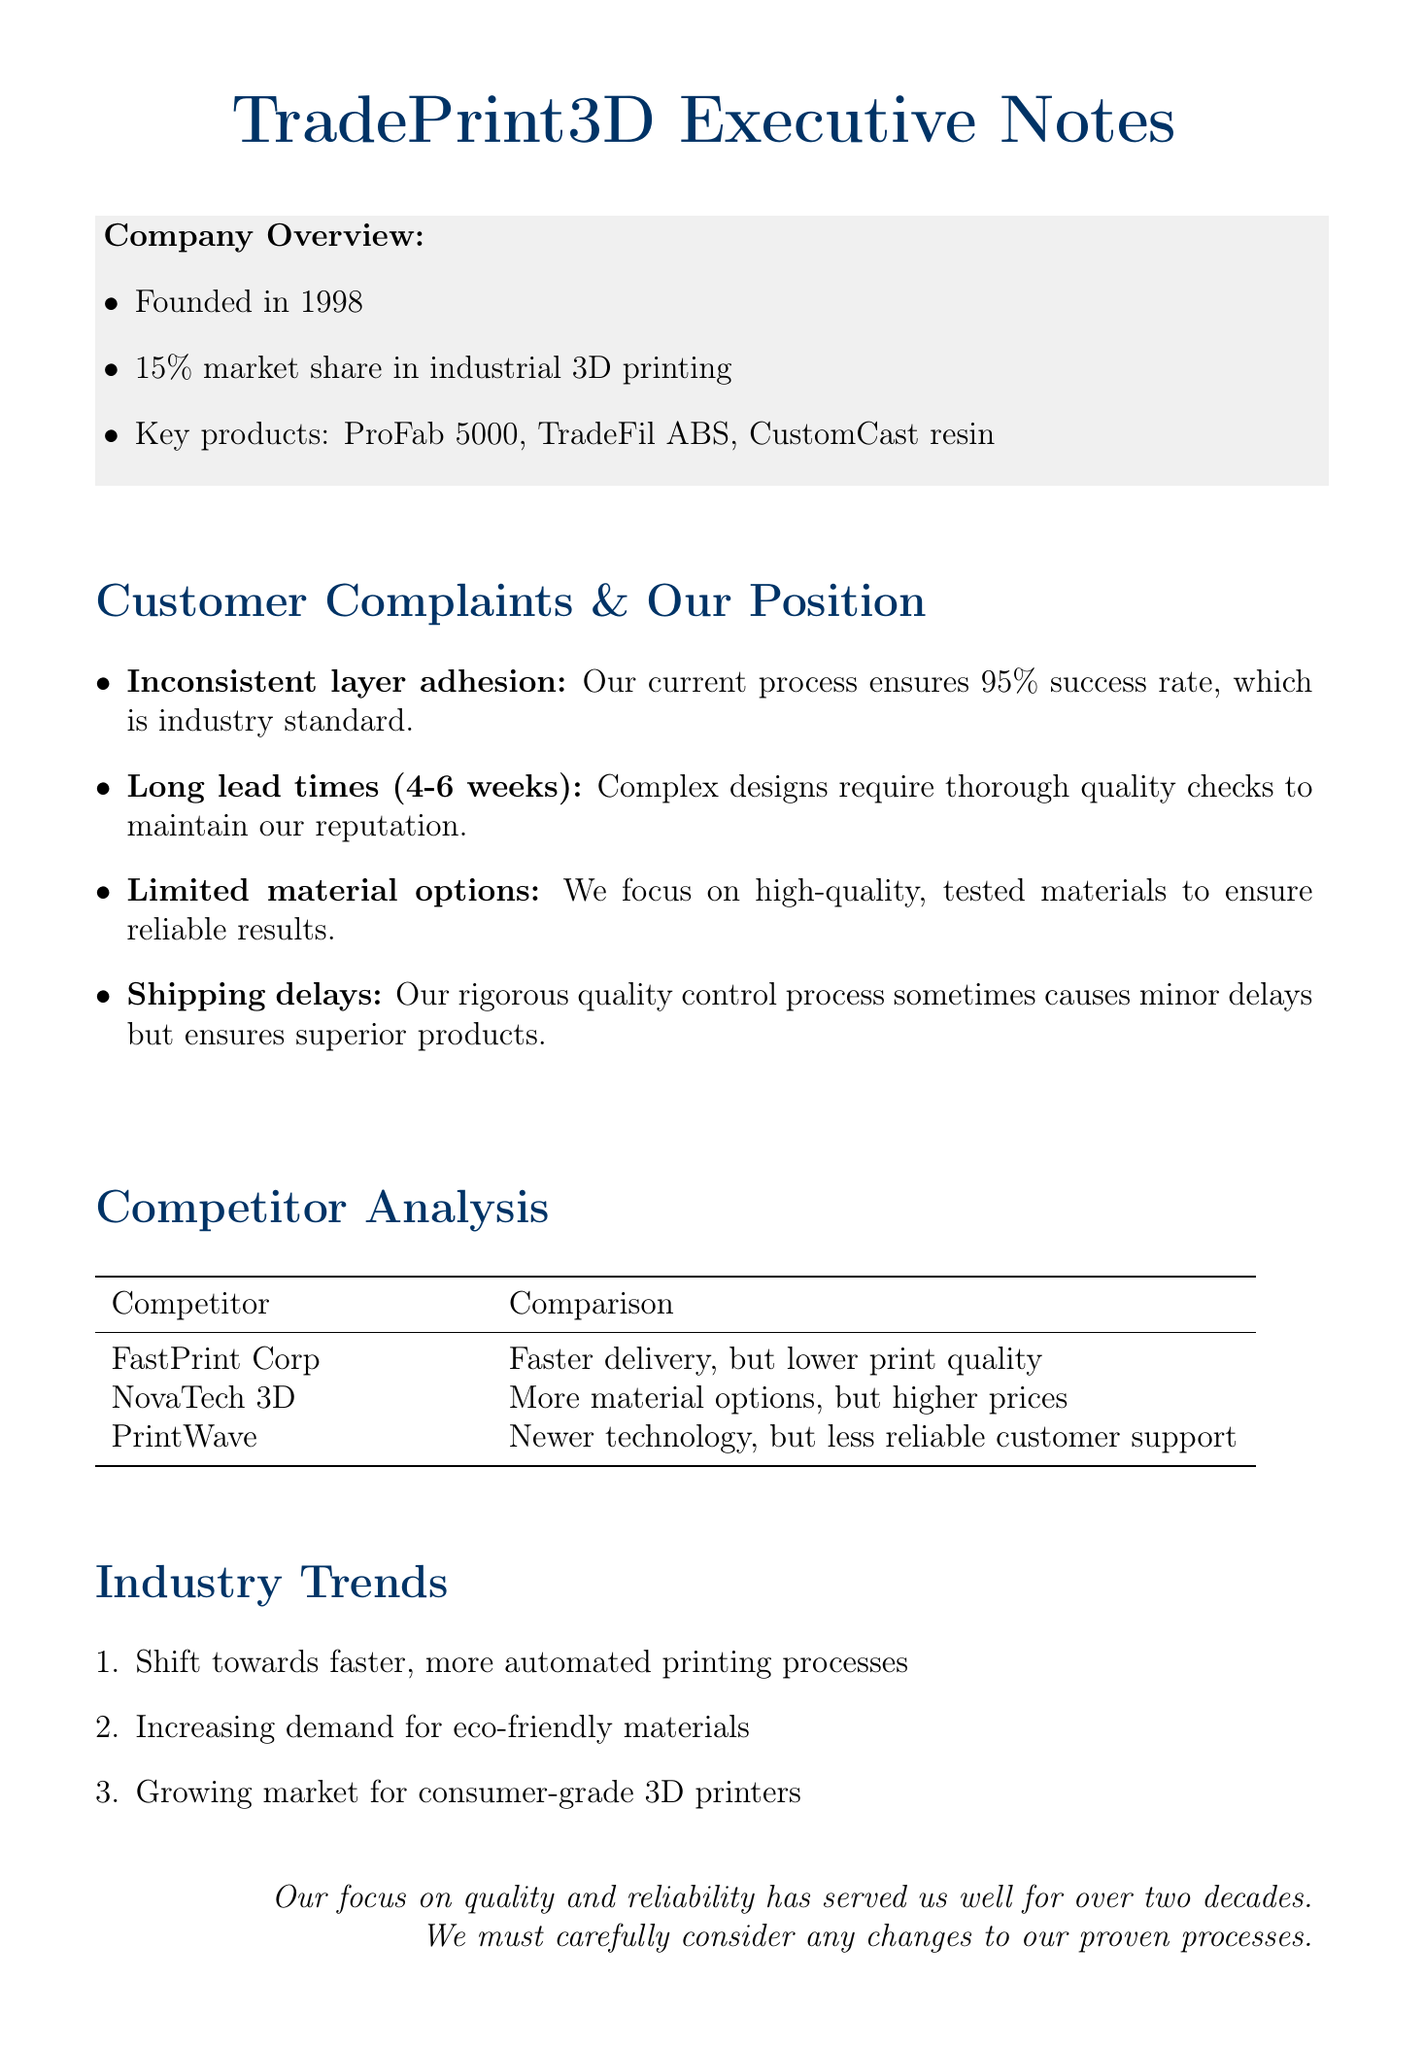What is the founding year of TradePrint3D? The founding year of TradePrint3D is mentioned in the document as 1998.
Answer: 1998 What is the market share of TradePrint3D? The market share of TradePrint3D in the industrial 3D printing market is noted as 15%.
Answer: 15% What is the lead time for custom orders? The document states that the lead time for custom orders is between 4 to 6 weeks.
Answer: 4-6 weeks What percentage success rate does TradePrint3D ensure in their process? The document mentions that TradePrint3D ensures a 95% success rate in their printing process.
Answer: 95% Which product is listed as an industrial printer? The key product listed as an industrial printer in the document is ProFab 5000.
Answer: ProFab 5000 What is the primary reason for long lead times according to the document? The document cites that complex designs require thorough quality checks to maintain the company's reputation as the primary reason for long lead times.
Answer: Thorough quality checks How does FastPrint Corp compare to TradePrint3D? According to the document, FastPrint Corp is noted for faster delivery but lower print quality compared to TradePrint3D.
Answer: Faster delivery, but lower print quality What are two trends mentioned in the industry trends section? The document lists the shift towards faster, automated printing processes and increasing demand for eco-friendly materials as two of the industry trends.
Answer: Faster, automated printing processes; eco-friendly materials 